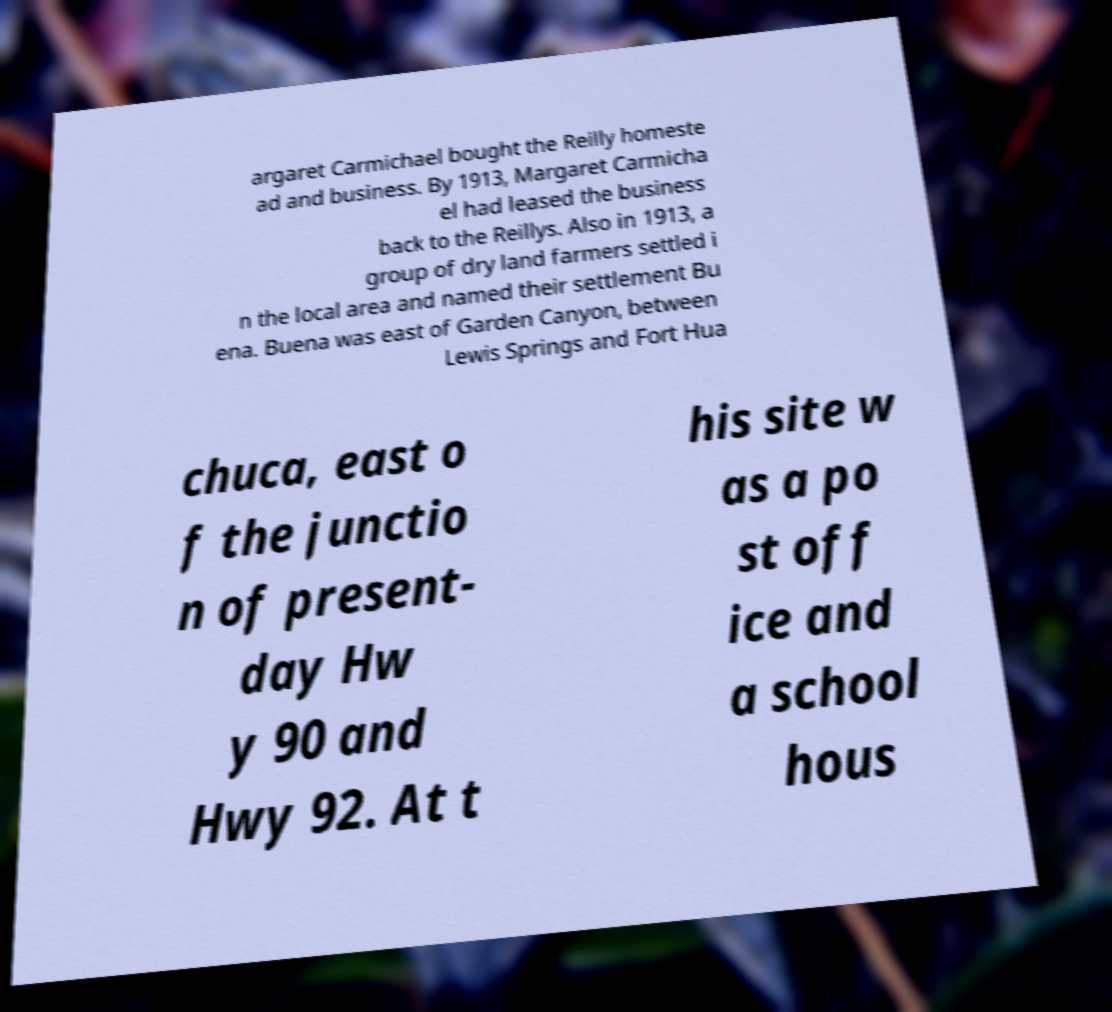I need the written content from this picture converted into text. Can you do that? argaret Carmichael bought the Reilly homeste ad and business. By 1913, Margaret Carmicha el had leased the business back to the Reillys. Also in 1913, a group of dry land farmers settled i n the local area and named their settlement Bu ena. Buena was east of Garden Canyon, between Lewis Springs and Fort Hua chuca, east o f the junctio n of present- day Hw y 90 and Hwy 92. At t his site w as a po st off ice and a school hous 